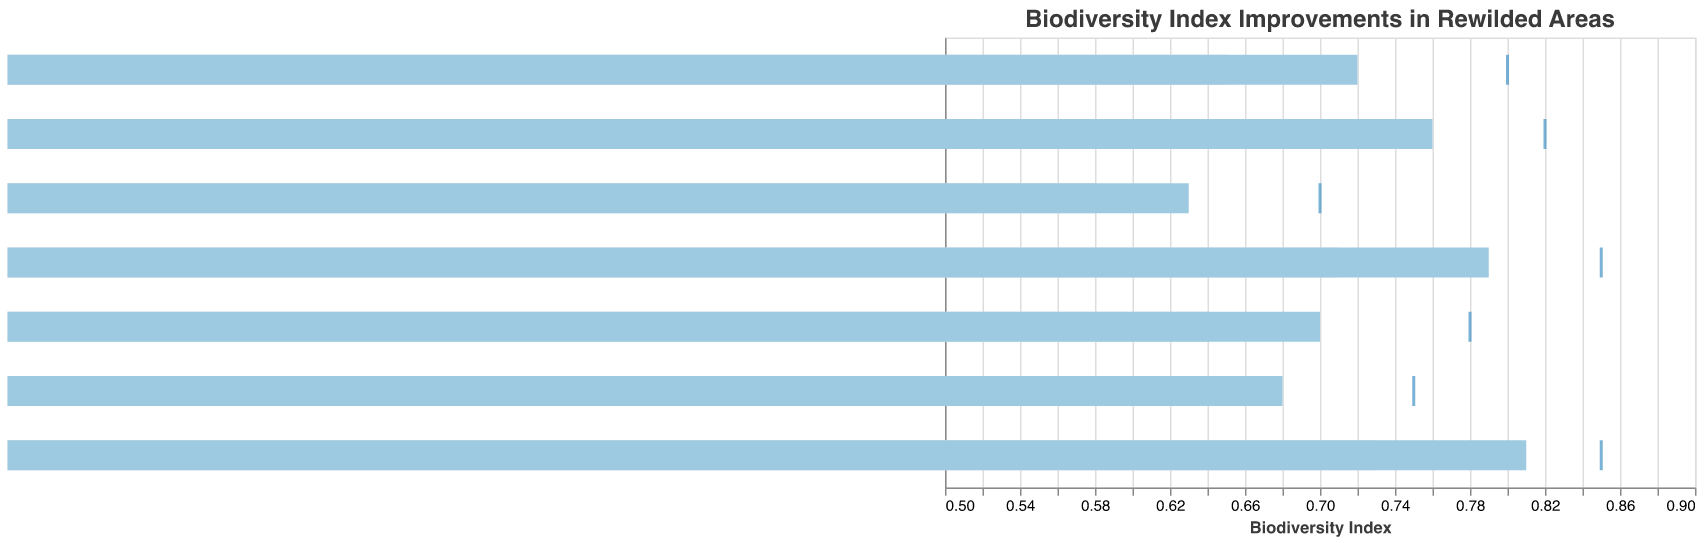How many habitat types are displayed in the figure? Count the number of unique categories representing habitat types in the figure.
Answer: 7 What is the title of the graph? Look at the top of the graph to find the title.
Answer: Biodiversity Index Improvements in Rewilded Areas Which habitat type has the highest actual biodiversity index? Identify the bar representing the highest actual value in the chart.
Answer: Wetlands What is the actual biodiversity index for Temperate Forests? Find the blue bar corresponding to Temperate Forests and read its value.
Answer: 0.68 Which habitat type has the largest positive difference between its actual index and the regional average? Compute the difference between the actual index and regional average for each habitat type, then determine the largest value. Wetlands: 0.81-0.73=0.08, Peatlands: 0.79-0.71=0.08, Coastal Dunes: 0.76-0.69=0.07, Alpine Meadows: 0.72-0.65=0.07, River Floodplains: 0.70-0.64=0.06, Temperate Forests: 0.68-0.62=0.06, Grasslands: 0.63-0.58=0.05.
Answer: Wetlands/Peatlands What is the overall range of the Target biodiversity index values shown in the graph? Identify the lowest and highest Target values in the chart and compute the range as the difference between them. Lowest is Grasslands: 0.70, Highest is Wetlands/Peatlands: 0.85, Range is 0.85-0.70=0.15
Answer: 0.15 How does the actual biodiversity index of Coastal Dunes compare to its target? Compare the blue bar's value for Coastal Dunes to its tick mark representing the target value.
Answer: Coastal Dunes actual: 0.76 is below target: 0.82 Which habitat types have not met their target biodiversity indices? Identify habitat types where the blue bar (actual) does not reach the tick mark (target value). Alpine Meadows: 0.72 < 0.80, Temperate Forests: 0.68 < 0.75, Grasslands: 0.63 < 0.70, Coastal Dunes: 0.76 < 0.82, River Floodplains: 0.70 < 0.78.
Answer: Alpine Meadows, Temperate Forests, Grasslands, Coastal Dunes, River Floodplains What is the average actual biodiversity index across all habitat types? Sum all actual values and divide by the number of habitat types. (0.72+0.68+0.81+0.63+0.76+0.70+0.79)/7 = 5.09/7 = 0.73
Answer: 0.73 Would you say wetlands and peatlands are performing better than their regional averages? Compare the actual index values for wetlands and peatlands to their respective regional averages. Wetlands: 0.81 > 0.73, Peatlands: 0.79 > 0.71.
Answer: Yes 